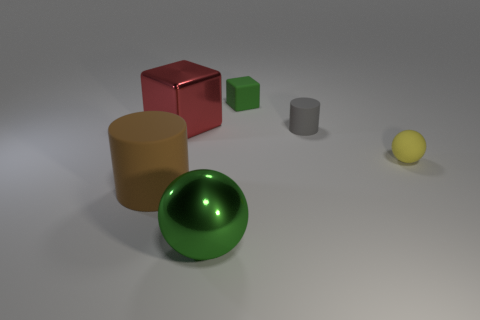Add 2 rubber blocks. How many rubber blocks exist? 3 Add 1 tiny matte cubes. How many objects exist? 7 Subtract 0 purple cylinders. How many objects are left? 6 Subtract all spheres. How many objects are left? 4 Subtract 2 cubes. How many cubes are left? 0 Subtract all yellow spheres. Subtract all blue cylinders. How many spheres are left? 1 Subtract all cyan balls. How many green cubes are left? 1 Subtract all tiny green matte blocks. Subtract all cylinders. How many objects are left? 3 Add 1 cylinders. How many cylinders are left? 3 